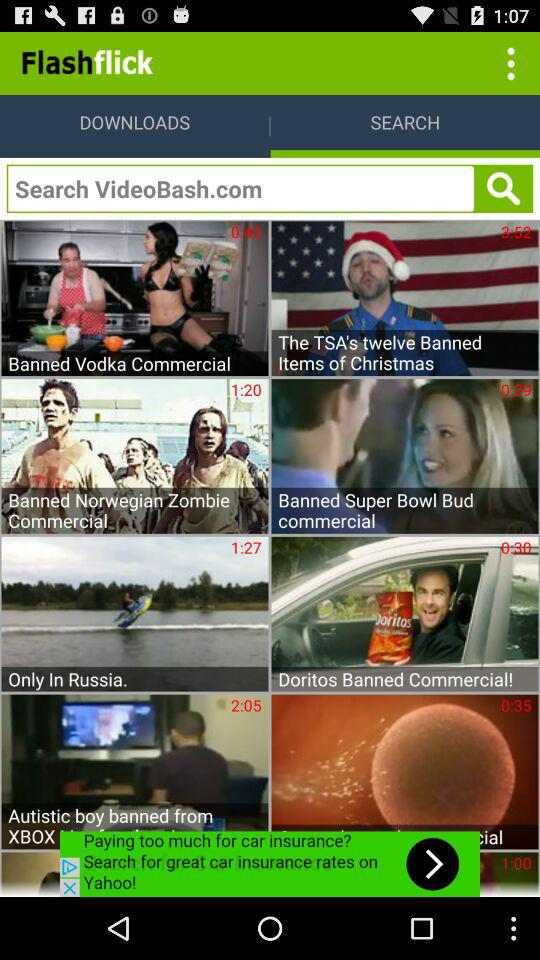Which video has a duration of 3:52? The video that has a duration of 3 minutes 52 seconds is "The TSA's twelve Banned Items of Christmas". 